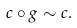Convert formula to latex. <formula><loc_0><loc_0><loc_500><loc_500>c \circ g \sim c .</formula> 